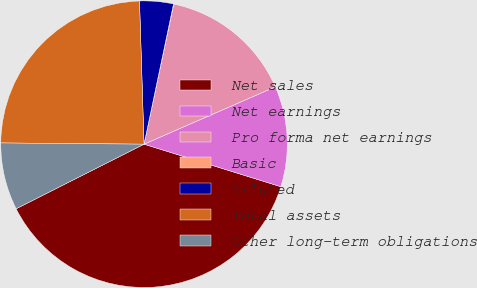Convert chart. <chart><loc_0><loc_0><loc_500><loc_500><pie_chart><fcel>Net sales<fcel>Net earnings<fcel>Pro forma net earnings<fcel>Basic<fcel>Diluted<fcel>Total assets<fcel>Other long-term obligations<nl><fcel>37.76%<fcel>11.35%<fcel>15.12%<fcel>0.03%<fcel>3.8%<fcel>24.36%<fcel>7.58%<nl></chart> 